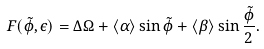Convert formula to latex. <formula><loc_0><loc_0><loc_500><loc_500>F ( \tilde { \phi } , \epsilon ) = \Delta \Omega + \langle \alpha \rangle \sin \tilde { \phi } + \langle \beta \rangle \sin \frac { \tilde { \phi } } { 2 } .</formula> 